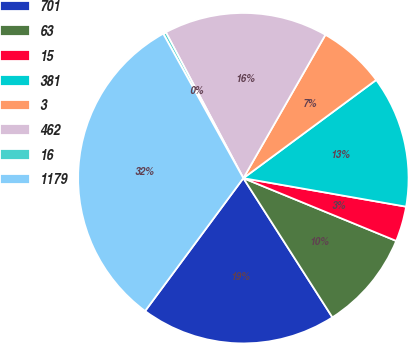Convert chart to OTSL. <chart><loc_0><loc_0><loc_500><loc_500><pie_chart><fcel>701<fcel>63<fcel>15<fcel>381<fcel>3<fcel>462<fcel>16<fcel>1179<nl><fcel>19.19%<fcel>9.74%<fcel>3.44%<fcel>12.89%<fcel>6.59%<fcel>16.04%<fcel>0.29%<fcel>31.8%<nl></chart> 